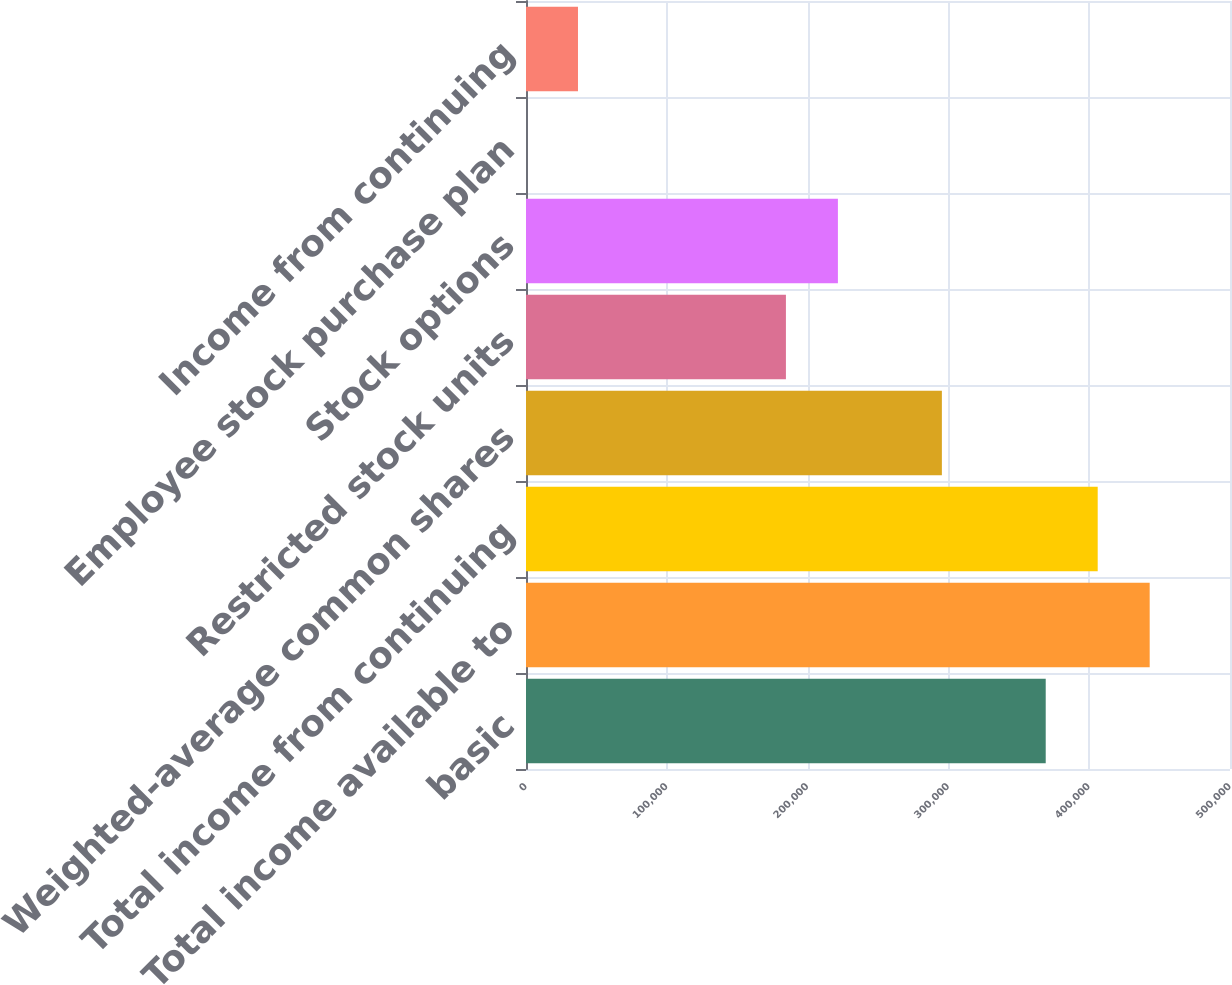<chart> <loc_0><loc_0><loc_500><loc_500><bar_chart><fcel>basic<fcel>Total income available to<fcel>Total income from continuing<fcel>Weighted-average common shares<fcel>Restricted stock units<fcel>Stock options<fcel>Employee stock purchase plan<fcel>Income from continuing<nl><fcel>369120<fcel>442960<fcel>406040<fcel>295364<fcel>184603<fcel>221523<fcel>2<fcel>36922.2<nl></chart> 